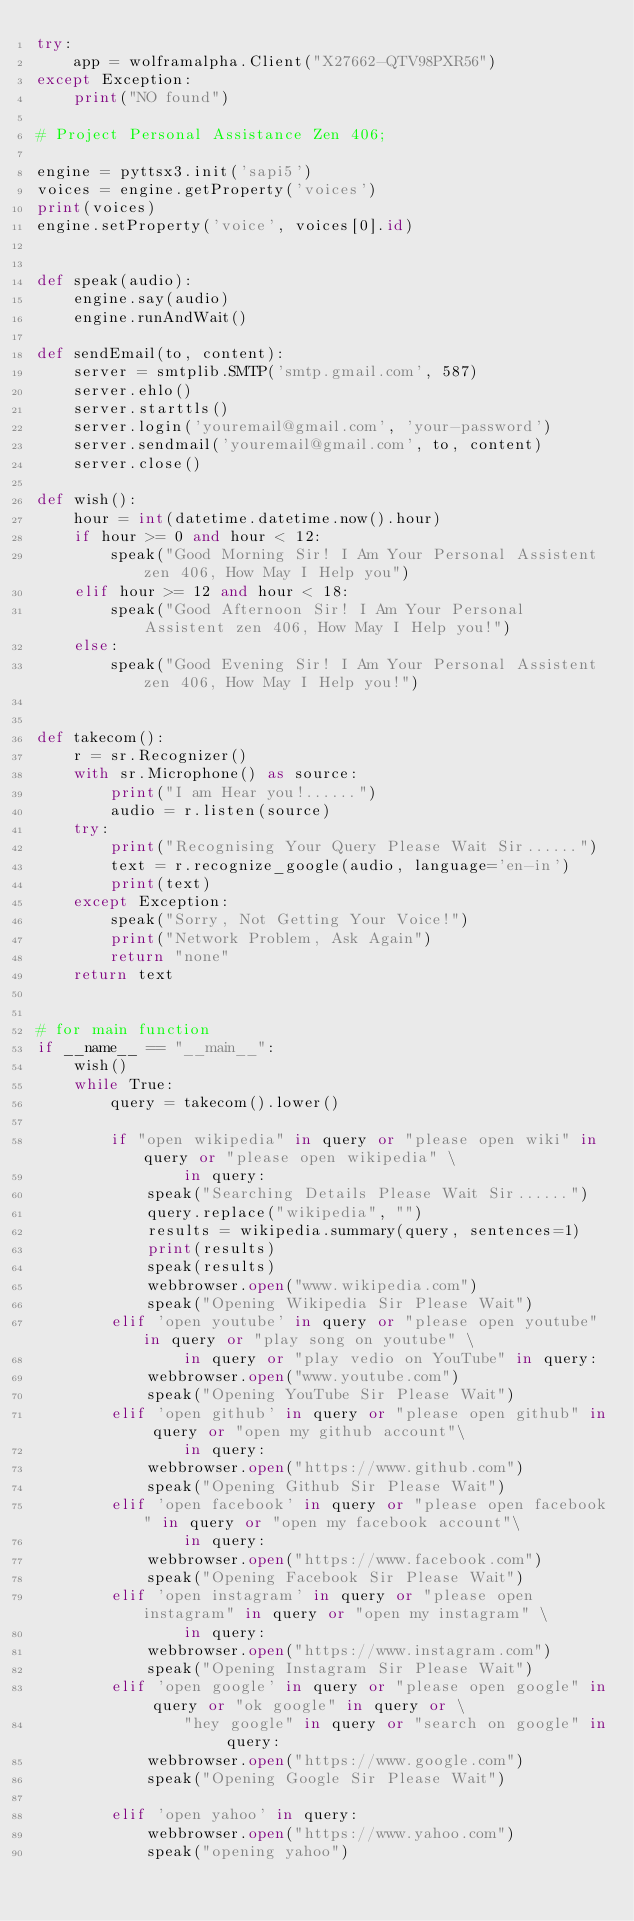Convert code to text. <code><loc_0><loc_0><loc_500><loc_500><_Python_>try:
    app = wolframalpha.Client("X27662-QTV98PXR56")
except Exception:
    print("NO found")

# Project Personal Assistance Zen 406;

engine = pyttsx3.init('sapi5')
voices = engine.getProperty('voices')
print(voices)
engine.setProperty('voice', voices[0].id)


def speak(audio):
    engine.say(audio)
    engine.runAndWait()

def sendEmail(to, content):
    server = smtplib.SMTP('smtp.gmail.com', 587)
    server.ehlo()
    server.starttls()
    server.login('youremail@gmail.com', 'your-password')
    server.sendmail('youremail@gmail.com', to, content)
    server.close()

def wish():
    hour = int(datetime.datetime.now().hour)
    if hour >= 0 and hour < 12:
        speak("Good Morning Sir! I Am Your Personal Assistent zen 406, How May I Help you")
    elif hour >= 12 and hour < 18:
        speak("Good Afternoon Sir! I Am Your Personal Assistent zen 406, How May I Help you!")
    else:
        speak("Good Evening Sir! I Am Your Personal Assistent zen 406, How May I Help you!")


def takecom():
    r = sr.Recognizer()
    with sr.Microphone() as source:
        print("I am Hear you!......")
        audio = r.listen(source)
    try:
        print("Recognising Your Query Please Wait Sir......")
        text = r.recognize_google(audio, language='en-in')
        print(text)
    except Exception:
        speak("Sorry, Not Getting Your Voice!")
        print("Network Problem, Ask Again")
        return "none"
    return text


# for main function
if __name__ == "__main__":
    wish()
    while True:
        query = takecom().lower()

        if "open wikipedia" in query or "please open wiki" in query or "please open wikipedia" \
                in query:
            speak("Searching Details Please Wait Sir......")
            query.replace("wikipedia", "")
            results = wikipedia.summary(query, sentences=1)
            print(results)
            speak(results)
            webbrowser.open("www.wikipedia.com")
            speak("Opening Wikipedia Sir Please Wait")
        elif 'open youtube' in query or "please open youtube" in query or "play song on youtube" \
                in query or "play vedio on YouTube" in query:
            webbrowser.open("www.youtube.com")
            speak("Opening YouTube Sir Please Wait")
        elif 'open github' in query or "please open github" in query or "open my github account"\
                in query:
            webbrowser.open("https://www.github.com")
            speak("Opening Github Sir Please Wait")
        elif 'open facebook' in query or "please open facebook" in query or "open my facebook account"\
                in query:
            webbrowser.open("https://www.facebook.com")
            speak("Opening Facebook Sir Please Wait")
        elif 'open instagram' in query or "please open instagram" in query or "open my instagram" \
                in query:
            webbrowser.open("https://www.instagram.com")
            speak("Opening Instagram Sir Please Wait")
        elif 'open google' in query or "please open google" in query or "ok google" in query or \
                "hey google" in query or "search on google" in query:
            webbrowser.open("https://www.google.com")
            speak("Opening Google Sir Please Wait")

        elif 'open yahoo' in query:
            webbrowser.open("https://www.yahoo.com")
            speak("opening yahoo")
</code> 